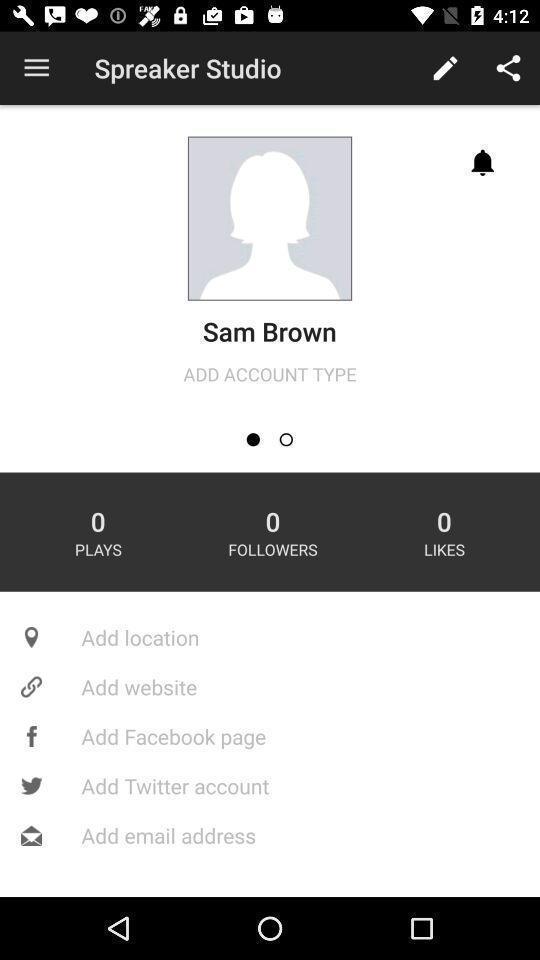Describe the content in this image. Page with different options and menu. 